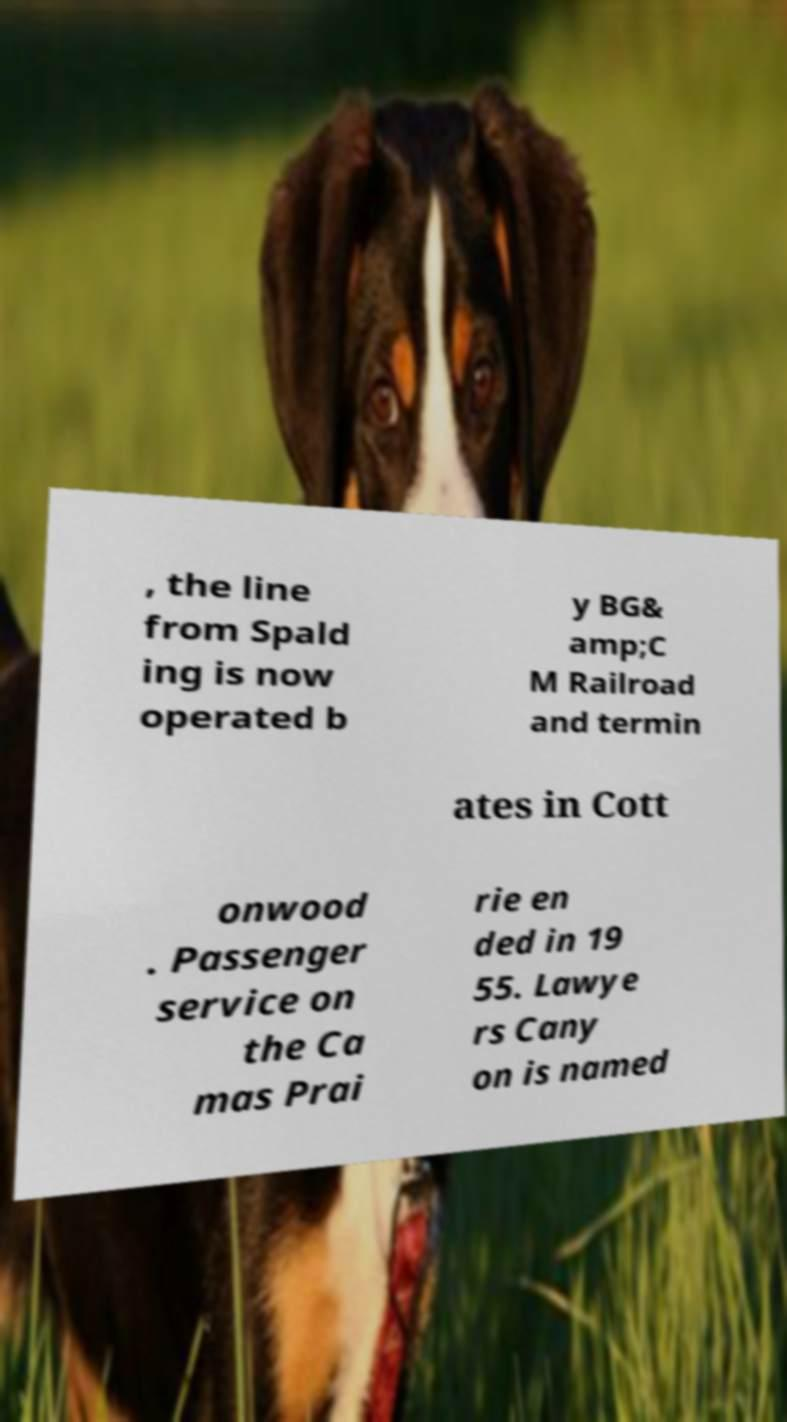Could you extract and type out the text from this image? , the line from Spald ing is now operated b y BG& amp;C M Railroad and termin ates in Cott onwood . Passenger service on the Ca mas Prai rie en ded in 19 55. Lawye rs Cany on is named 